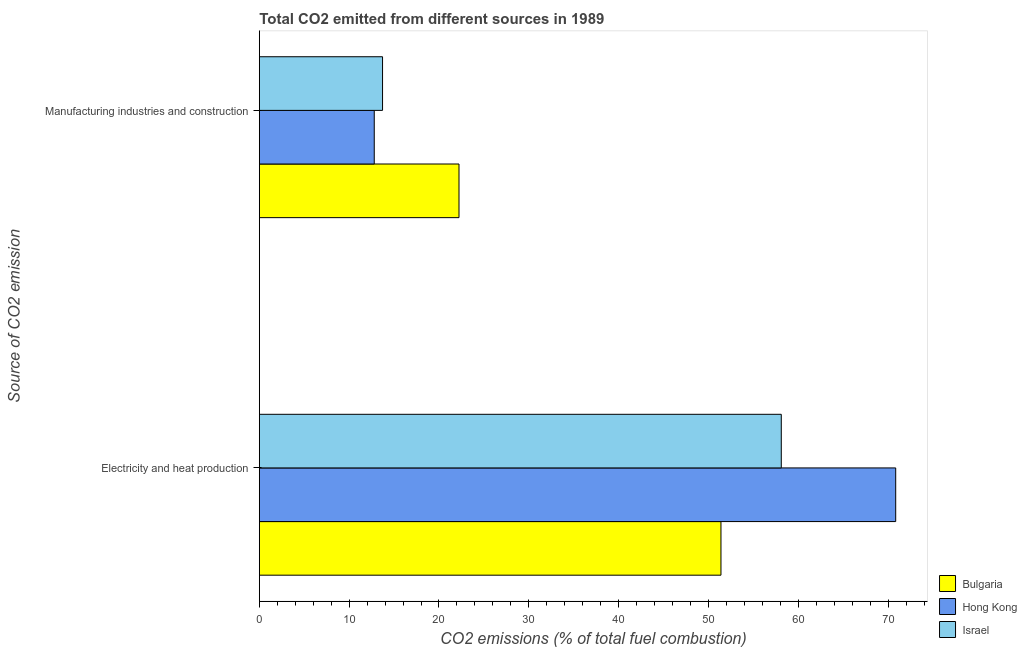How many groups of bars are there?
Your response must be concise. 2. How many bars are there on the 2nd tick from the top?
Your answer should be very brief. 3. How many bars are there on the 1st tick from the bottom?
Give a very brief answer. 3. What is the label of the 1st group of bars from the top?
Provide a short and direct response. Manufacturing industries and construction. What is the co2 emissions due to electricity and heat production in Bulgaria?
Give a very brief answer. 51.39. Across all countries, what is the maximum co2 emissions due to electricity and heat production?
Your answer should be very brief. 70.85. Across all countries, what is the minimum co2 emissions due to electricity and heat production?
Give a very brief answer. 51.39. In which country was the co2 emissions due to electricity and heat production maximum?
Give a very brief answer. Hong Kong. In which country was the co2 emissions due to manufacturing industries minimum?
Ensure brevity in your answer.  Hong Kong. What is the total co2 emissions due to manufacturing industries in the graph?
Keep it short and to the point. 48.74. What is the difference between the co2 emissions due to manufacturing industries in Bulgaria and that in Israel?
Provide a succinct answer. 8.51. What is the difference between the co2 emissions due to manufacturing industries in Bulgaria and the co2 emissions due to electricity and heat production in Hong Kong?
Provide a short and direct response. -48.62. What is the average co2 emissions due to electricity and heat production per country?
Make the answer very short. 60.12. What is the difference between the co2 emissions due to manufacturing industries and co2 emissions due to electricity and heat production in Hong Kong?
Keep it short and to the point. -58.05. What is the ratio of the co2 emissions due to manufacturing industries in Israel to that in Hong Kong?
Provide a short and direct response. 1.07. Is the co2 emissions due to manufacturing industries in Bulgaria less than that in Israel?
Offer a very short reply. No. What does the 2nd bar from the top in Electricity and heat production represents?
Your answer should be very brief. Hong Kong. Are all the bars in the graph horizontal?
Keep it short and to the point. Yes. Are the values on the major ticks of X-axis written in scientific E-notation?
Make the answer very short. No. Does the graph contain any zero values?
Your response must be concise. No. How many legend labels are there?
Ensure brevity in your answer.  3. How are the legend labels stacked?
Ensure brevity in your answer.  Vertical. What is the title of the graph?
Offer a very short reply. Total CO2 emitted from different sources in 1989. Does "Argentina" appear as one of the legend labels in the graph?
Keep it short and to the point. No. What is the label or title of the X-axis?
Keep it short and to the point. CO2 emissions (% of total fuel combustion). What is the label or title of the Y-axis?
Offer a very short reply. Source of CO2 emission. What is the CO2 emissions (% of total fuel combustion) in Bulgaria in Electricity and heat production?
Offer a terse response. 51.39. What is the CO2 emissions (% of total fuel combustion) in Hong Kong in Electricity and heat production?
Your answer should be compact. 70.85. What is the CO2 emissions (% of total fuel combustion) of Israel in Electricity and heat production?
Keep it short and to the point. 58.11. What is the CO2 emissions (% of total fuel combustion) in Bulgaria in Manufacturing industries and construction?
Your response must be concise. 22.23. What is the CO2 emissions (% of total fuel combustion) of Hong Kong in Manufacturing industries and construction?
Your answer should be very brief. 12.79. What is the CO2 emissions (% of total fuel combustion) of Israel in Manufacturing industries and construction?
Keep it short and to the point. 13.72. Across all Source of CO2 emission, what is the maximum CO2 emissions (% of total fuel combustion) of Bulgaria?
Give a very brief answer. 51.39. Across all Source of CO2 emission, what is the maximum CO2 emissions (% of total fuel combustion) in Hong Kong?
Offer a very short reply. 70.85. Across all Source of CO2 emission, what is the maximum CO2 emissions (% of total fuel combustion) in Israel?
Ensure brevity in your answer.  58.11. Across all Source of CO2 emission, what is the minimum CO2 emissions (% of total fuel combustion) of Bulgaria?
Provide a short and direct response. 22.23. Across all Source of CO2 emission, what is the minimum CO2 emissions (% of total fuel combustion) in Hong Kong?
Make the answer very short. 12.79. Across all Source of CO2 emission, what is the minimum CO2 emissions (% of total fuel combustion) of Israel?
Ensure brevity in your answer.  13.72. What is the total CO2 emissions (% of total fuel combustion) of Bulgaria in the graph?
Your answer should be very brief. 73.62. What is the total CO2 emissions (% of total fuel combustion) in Hong Kong in the graph?
Offer a very short reply. 83.64. What is the total CO2 emissions (% of total fuel combustion) in Israel in the graph?
Give a very brief answer. 71.83. What is the difference between the CO2 emissions (% of total fuel combustion) of Bulgaria in Electricity and heat production and that in Manufacturing industries and construction?
Provide a succinct answer. 29.17. What is the difference between the CO2 emissions (% of total fuel combustion) in Hong Kong in Electricity and heat production and that in Manufacturing industries and construction?
Provide a short and direct response. 58.05. What is the difference between the CO2 emissions (% of total fuel combustion) of Israel in Electricity and heat production and that in Manufacturing industries and construction?
Provide a short and direct response. 44.39. What is the difference between the CO2 emissions (% of total fuel combustion) in Bulgaria in Electricity and heat production and the CO2 emissions (% of total fuel combustion) in Hong Kong in Manufacturing industries and construction?
Your answer should be very brief. 38.6. What is the difference between the CO2 emissions (% of total fuel combustion) in Bulgaria in Electricity and heat production and the CO2 emissions (% of total fuel combustion) in Israel in Manufacturing industries and construction?
Provide a short and direct response. 37.68. What is the difference between the CO2 emissions (% of total fuel combustion) in Hong Kong in Electricity and heat production and the CO2 emissions (% of total fuel combustion) in Israel in Manufacturing industries and construction?
Provide a short and direct response. 57.13. What is the average CO2 emissions (% of total fuel combustion) in Bulgaria per Source of CO2 emission?
Make the answer very short. 36.81. What is the average CO2 emissions (% of total fuel combustion) of Hong Kong per Source of CO2 emission?
Provide a short and direct response. 41.82. What is the average CO2 emissions (% of total fuel combustion) of Israel per Source of CO2 emission?
Ensure brevity in your answer.  35.91. What is the difference between the CO2 emissions (% of total fuel combustion) of Bulgaria and CO2 emissions (% of total fuel combustion) of Hong Kong in Electricity and heat production?
Your answer should be very brief. -19.45. What is the difference between the CO2 emissions (% of total fuel combustion) of Bulgaria and CO2 emissions (% of total fuel combustion) of Israel in Electricity and heat production?
Give a very brief answer. -6.72. What is the difference between the CO2 emissions (% of total fuel combustion) of Hong Kong and CO2 emissions (% of total fuel combustion) of Israel in Electricity and heat production?
Keep it short and to the point. 12.74. What is the difference between the CO2 emissions (% of total fuel combustion) in Bulgaria and CO2 emissions (% of total fuel combustion) in Hong Kong in Manufacturing industries and construction?
Offer a terse response. 9.43. What is the difference between the CO2 emissions (% of total fuel combustion) in Bulgaria and CO2 emissions (% of total fuel combustion) in Israel in Manufacturing industries and construction?
Provide a succinct answer. 8.51. What is the difference between the CO2 emissions (% of total fuel combustion) of Hong Kong and CO2 emissions (% of total fuel combustion) of Israel in Manufacturing industries and construction?
Make the answer very short. -0.92. What is the ratio of the CO2 emissions (% of total fuel combustion) in Bulgaria in Electricity and heat production to that in Manufacturing industries and construction?
Ensure brevity in your answer.  2.31. What is the ratio of the CO2 emissions (% of total fuel combustion) in Hong Kong in Electricity and heat production to that in Manufacturing industries and construction?
Give a very brief answer. 5.54. What is the ratio of the CO2 emissions (% of total fuel combustion) of Israel in Electricity and heat production to that in Manufacturing industries and construction?
Your answer should be very brief. 4.24. What is the difference between the highest and the second highest CO2 emissions (% of total fuel combustion) in Bulgaria?
Your answer should be compact. 29.17. What is the difference between the highest and the second highest CO2 emissions (% of total fuel combustion) of Hong Kong?
Ensure brevity in your answer.  58.05. What is the difference between the highest and the second highest CO2 emissions (% of total fuel combustion) in Israel?
Make the answer very short. 44.39. What is the difference between the highest and the lowest CO2 emissions (% of total fuel combustion) in Bulgaria?
Keep it short and to the point. 29.17. What is the difference between the highest and the lowest CO2 emissions (% of total fuel combustion) in Hong Kong?
Give a very brief answer. 58.05. What is the difference between the highest and the lowest CO2 emissions (% of total fuel combustion) in Israel?
Provide a succinct answer. 44.39. 